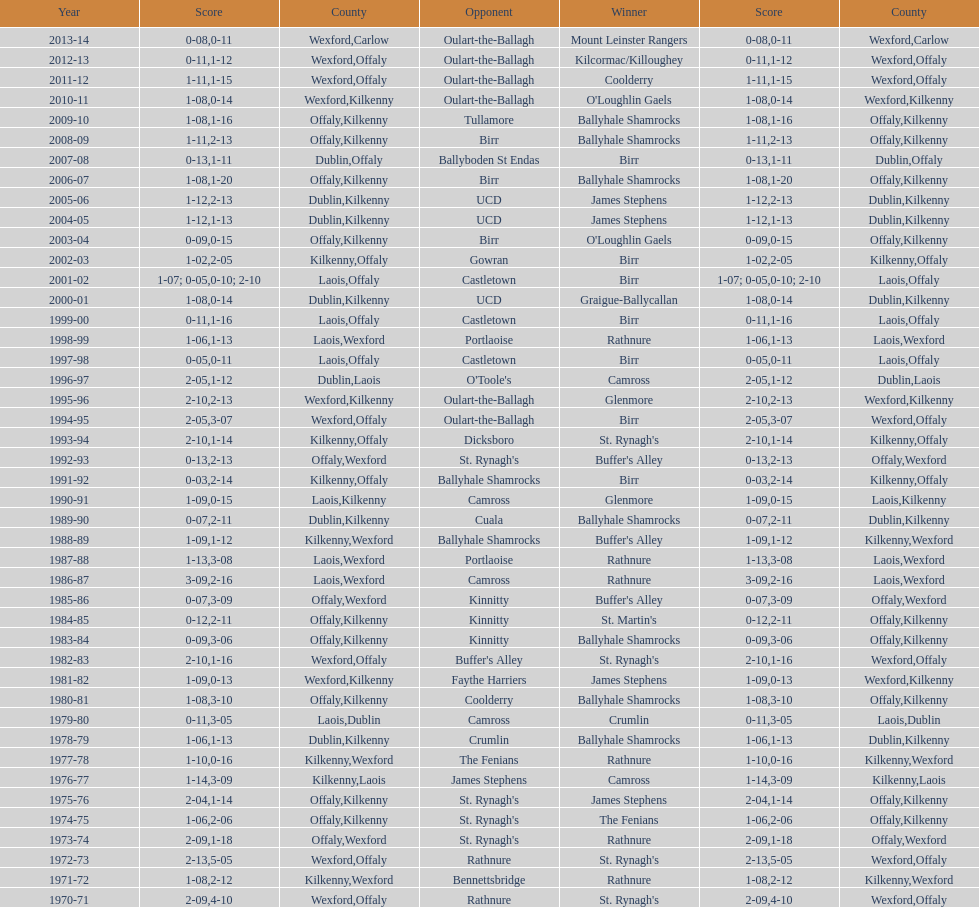Which country had the most wins? Kilkenny. 